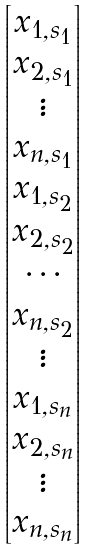Convert formula to latex. <formula><loc_0><loc_0><loc_500><loc_500>\begin{bmatrix} x _ { 1 , s _ { 1 } } \\ x _ { 2 , s _ { 1 } } \\ \vdots \\ x _ { n , s _ { 1 } } \\ x _ { 1 , s _ { 2 } } \\ x _ { 2 , s _ { 2 } } \\ \cdots \\ x _ { n , s _ { 2 } } \\ \vdots \\ x _ { 1 , s _ { n } } \\ x _ { 2 , s _ { n } } \\ \vdots \\ x _ { n , s _ { n } } \end{bmatrix}</formula> 